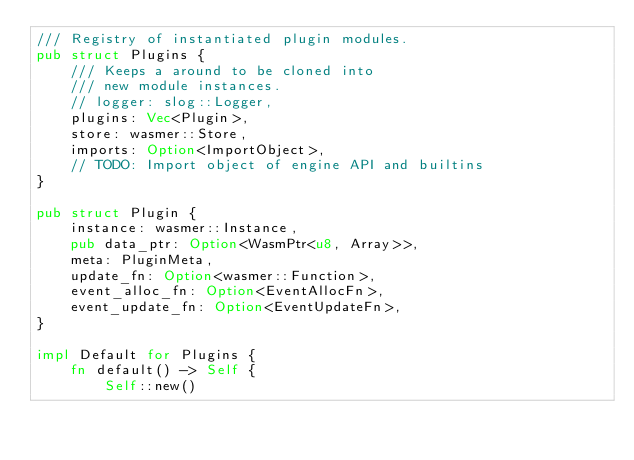<code> <loc_0><loc_0><loc_500><loc_500><_Rust_>/// Registry of instantiated plugin modules.
pub struct Plugins {
    /// Keeps a around to be cloned into
    /// new module instances.
    // logger: slog::Logger,
    plugins: Vec<Plugin>,
    store: wasmer::Store,
    imports: Option<ImportObject>,
    // TODO: Import object of engine API and builtins
}

pub struct Plugin {
    instance: wasmer::Instance,
    pub data_ptr: Option<WasmPtr<u8, Array>>,
    meta: PluginMeta,
    update_fn: Option<wasmer::Function>,
    event_alloc_fn: Option<EventAllocFn>,
    event_update_fn: Option<EventUpdateFn>,
}

impl Default for Plugins {
    fn default() -> Self {
        Self::new()</code> 